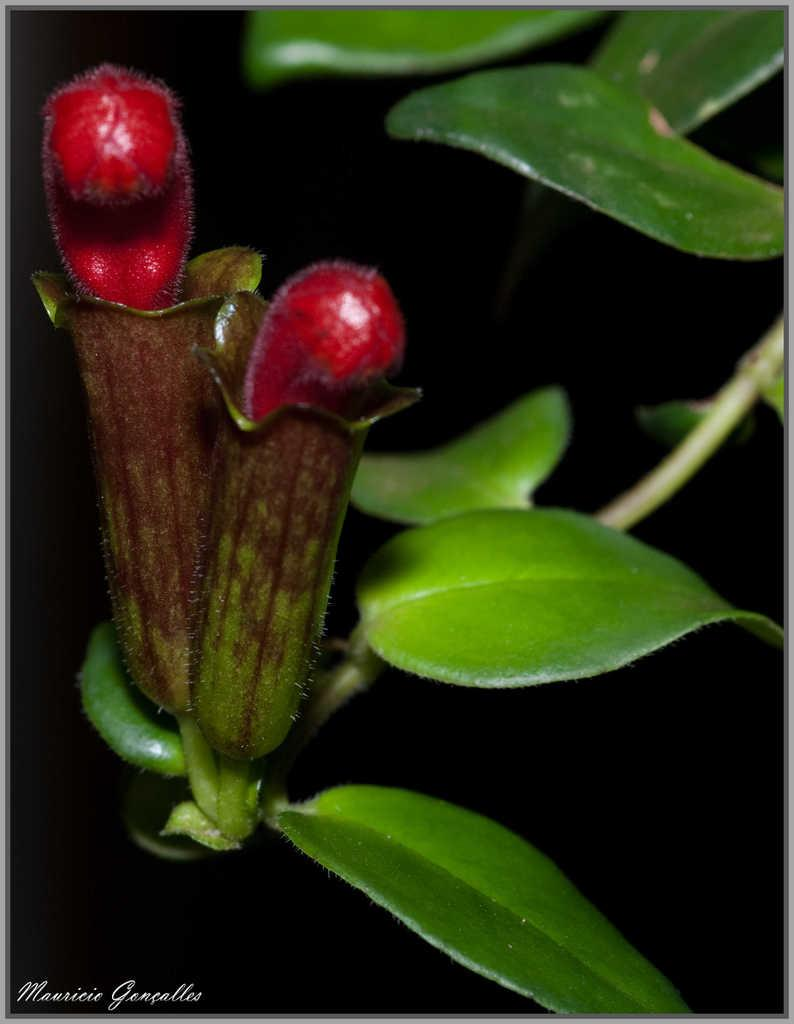What type of living organisms can be seen in the image? There are flowers on a plant in the image. How many houses can be seen in the image? There are no houses present in the image; it features a plant with flowers. What type of religious building can be seen in the image? There is no religious building, such as a church, present in the image. 